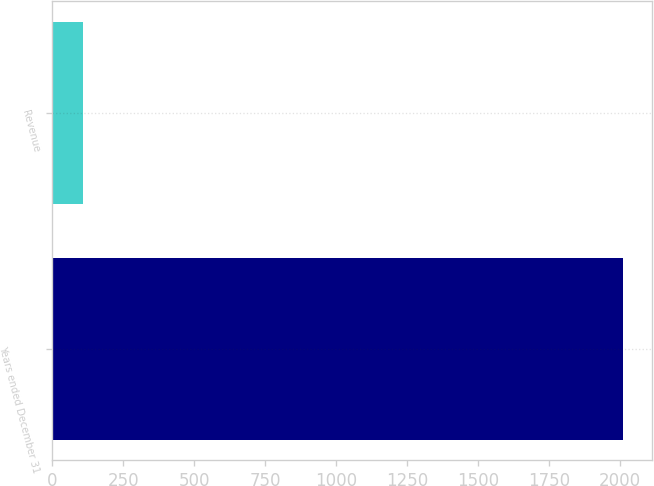Convert chart to OTSL. <chart><loc_0><loc_0><loc_500><loc_500><bar_chart><fcel>Years ended December 31<fcel>Revenue<nl><fcel>2012<fcel>106<nl></chart> 